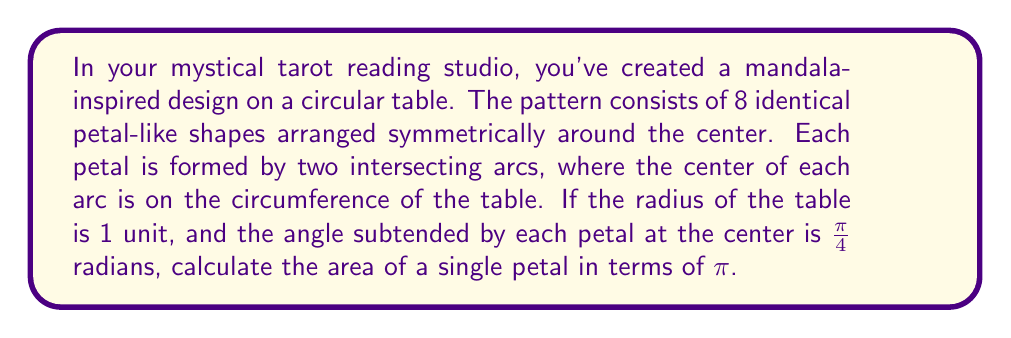Solve this math problem. Let's approach this mystical geometry step-by-step:

1) First, let's visualize the mandala pattern:

[asy]
unitsize(2cm);
draw(circle((0,0),1));
for(int i=0; i<8; ++i) {
  draw(arc((cos(pi/4*i),sin(pi/4*i)),1,180+45*i,180+45*(i+1)));
  draw(arc((cos(pi/4*(i+1)),sin(pi/4*(i+1))),1,180+45*(i+1),180+45*(i+2)));
}
[/asy]

2) Each petal is formed by two circular segments. The area of the petal is the difference between the area of the sector and the area of the triangle formed by the two radii.

3) The angle subtended by each petal at the center is $\frac{\pi}{4}$ radians or 45°.

4) Area of the sector:
   $$A_{sector} = \frac{1}{2} r^2 \theta = \frac{1}{2} \cdot 1^2 \cdot \frac{\pi}{4} = \frac{\pi}{8}$$

5) For the triangle, we need to find its height:
   $$h = \sin(\frac{\pi}{8}) = \sin(22.5°)$$

6) Area of the triangle:
   $$A_{triangle} = \frac{1}{2} \cdot 1 \cdot 1 \cdot \sin(\frac{\pi}{8}) = \frac{1}{2}\sin(\frac{\pi}{8})$$

7) Area of the petal:
   $$A_{petal} = A_{sector} - A_{triangle} = \frac{\pi}{8} - \frac{1}{2}\sin(\frac{\pi}{8})$$

8) Simplify:
   $$A_{petal} = \frac{\pi}{8} - \frac{1}{2}\sin(\frac{\pi}{8})$$

This expression represents the area of a single petal in terms of $\pi$.
Answer: $$\frac{\pi}{8} - \frac{1}{2}\sin(\frac{\pi}{8})$$ 